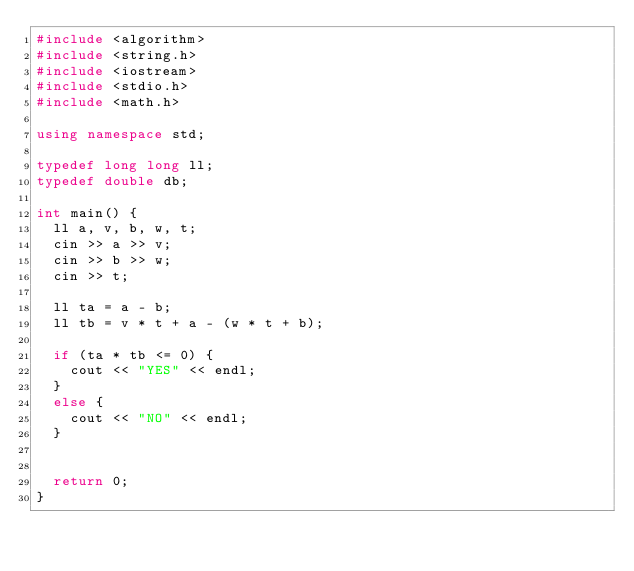Convert code to text. <code><loc_0><loc_0><loc_500><loc_500><_C++_>#include <algorithm>
#include <string.h>
#include <iostream>
#include <stdio.h>
#include <math.h>

using namespace std;

typedef long long ll;
typedef double db;

int main() {
	ll a, v, b, w, t;
	cin >> a >> v;
	cin >> b >> w;
	cin >> t;

	ll ta = a - b;
	ll tb = v * t + a - (w * t + b);

	if (ta * tb <= 0) {
		cout << "YES" << endl;
	}
	else {
		cout << "NO" << endl;
	}


	return 0;
}</code> 